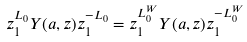<formula> <loc_0><loc_0><loc_500><loc_500>z _ { 1 } ^ { L _ { 0 } } Y ( a , z ) z _ { 1 } ^ { - L _ { 0 } } = z _ { 1 } ^ { L ^ { W } _ { 0 } } Y ( a , z ) z _ { 1 } ^ { - L ^ { W } _ { 0 } }</formula> 